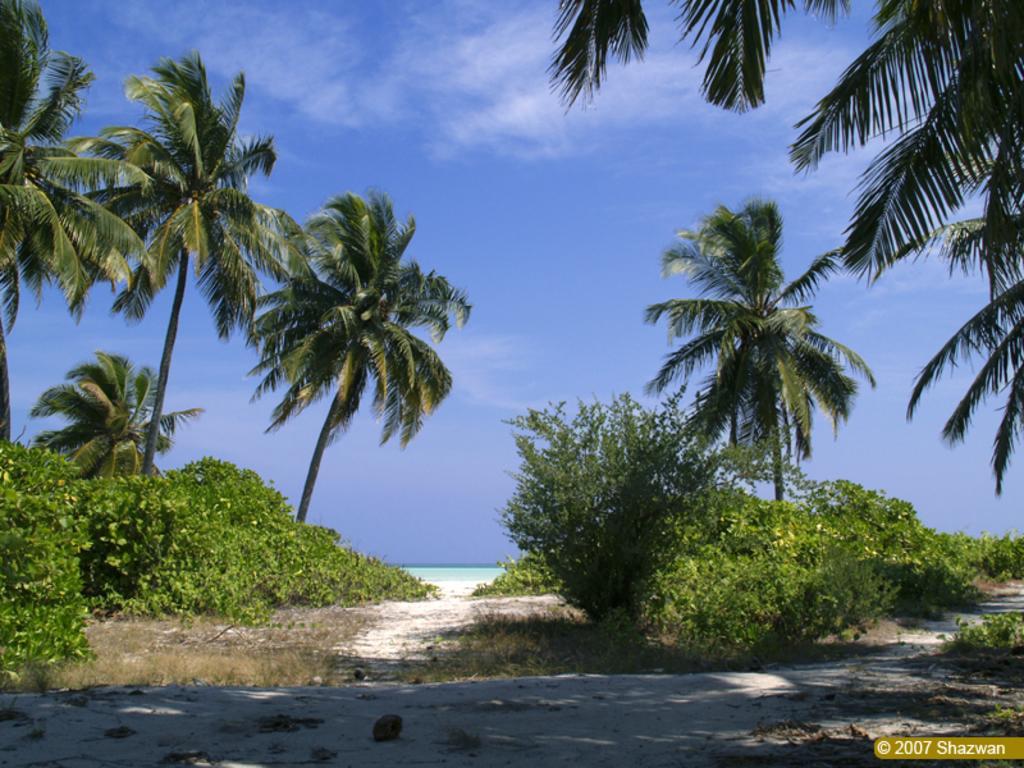In one or two sentences, can you explain what this image depicts? In this image there is sand, grass, plants, trees, water, sky and a watermark on the image. 